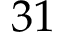<formula> <loc_0><loc_0><loc_500><loc_500>3 1</formula> 